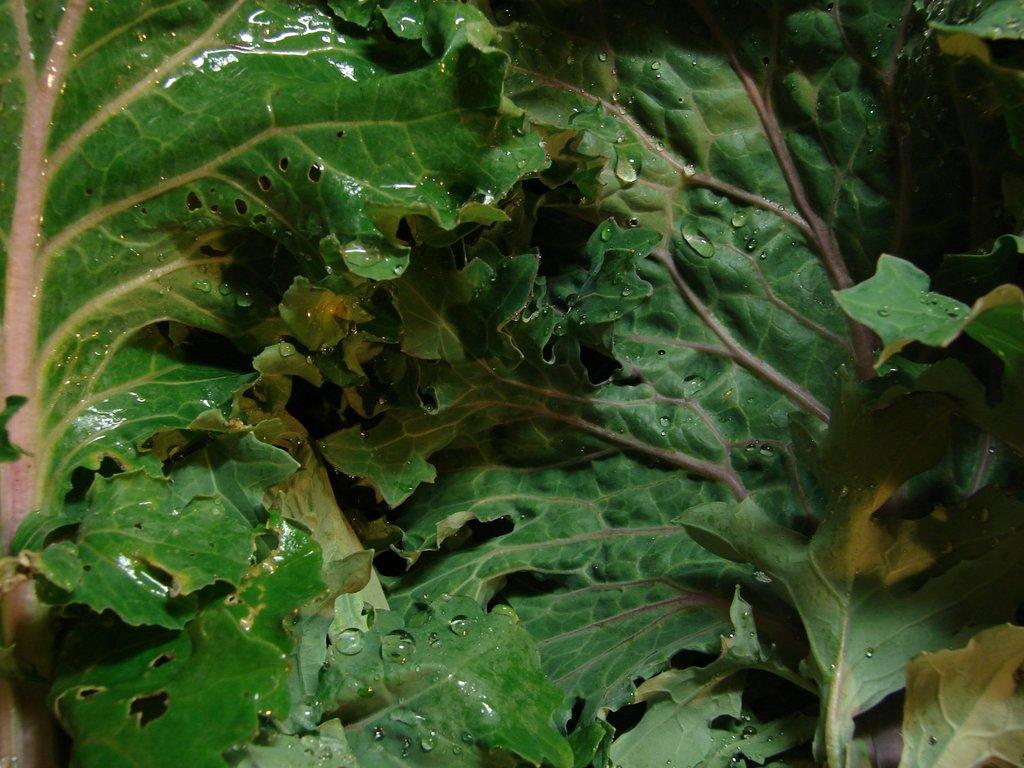Can you describe this image briefly? In this picture we can see water drops on the leaves. 